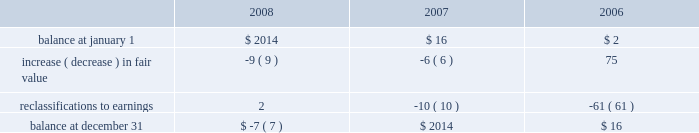Stockholders 2019 equity derivative instruments activity , net of tax , included in non-owner changes to equity within the consolidated statements of stockholders 2019 equity for the years ended december 31 , 2008 , 2007 and 2006 is as follows: .
Net investment in foreign operations hedge at december 31 , 2008 and 2007 , the company did not have any hedges of foreign currency exposure of net investments in foreign operations .
Investments hedge during the first quarter of 2006 , the company entered into a zero-cost collar derivative ( the 201csprint nextel derivative 201d ) to protect itself economically against price fluctuations in its 37.6 million shares of sprint nextel corporation ( 201csprint nextel 201d ) non-voting common stock .
During the second quarter of 2006 , as a result of sprint nextel 2019s spin-off of embarq corporation through a dividend to sprint nextel shareholders , the company received approximately 1.9 million shares of embarq corporation .
The floor and ceiling prices of the sprint nextel derivative were adjusted accordingly .
The sprint nextel derivative was not designated as a hedge under the provisions of sfas no .
133 , 201caccounting for derivative instruments and hedging activities . 201d accordingly , to reflect the change in fair value of the sprint nextel derivative , the company recorded a net gain of $ 99 million for the year ended december 31 , 2006 , included in other income ( expense ) in the company 2019s consolidated statements of operations .
In december 2006 , the sprint nextel derivative was terminated and settled in cash and the 37.6 million shares of sprint nextel were converted to common shares and sold .
The company received aggregate cash proceeds of approximately $ 820 million from the settlement of the sprint nextel derivative and the subsequent sale of the 37.6 million sprint nextel shares .
The company recognized a loss of $ 126 million in connection with the sale of the remaining shares of sprint nextel common stock .
As described above , the company recorded a net gain of $ 99 million in connection with the sprint nextel derivative .
Fair value of financial instruments the company 2019s financial instruments include cash equivalents , sigma fund investments , short-term investments , accounts receivable , long-term receivables , accounts payable , accrued liabilities , derivatives and other financing commitments .
The company 2019s sigma fund , available-for-sale investment portfolios and derivatives are recorded in the company 2019s consolidated balance sheets at fair value .
All other financial instruments , with the exception of long-term debt , are carried at cost , which is not materially different than the instruments 2019 fair values .
Using quoted market prices and market interest rates , the company determined that the fair value of long- term debt at december 31 , 2008 was $ 2.8 billion , compared to a carrying value of $ 4.1 billion .
Since considerable judgment is required in interpreting market information , the fair value of the long-term debt is not necessarily indicative of the amount which could be realized in a current market exchange .
Equity price market risk at december 31 , 2008 , the company 2019s available-for-sale equity securities portfolio had an approximate fair market value of $ 128 million , which represented a cost basis of $ 125 million and a net unrealized loss of $ 3 million .
These equity securities are held for purposes other than trading .
%%transmsg*** transmitting job : c49054 pcn : 105000000 ***%%pcmsg|102 |00022|yes|no|02/23/2009 19:17|0|0|page is valid , no graphics -- color : n| .
What was the percent change in balance of stockholder equity from the beginning to the end of 2006? 
Computations: ((16 - 2) / 2)
Answer: 7.0. 